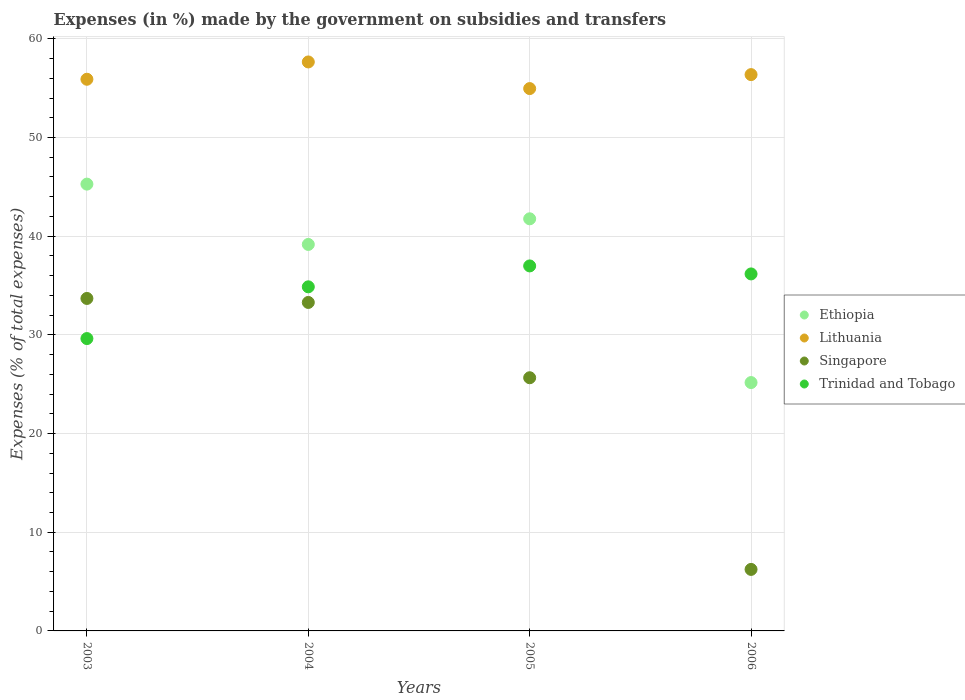Is the number of dotlines equal to the number of legend labels?
Your answer should be compact. Yes. What is the percentage of expenses made by the government on subsidies and transfers in Trinidad and Tobago in 2003?
Make the answer very short. 29.62. Across all years, what is the maximum percentage of expenses made by the government on subsidies and transfers in Lithuania?
Your response must be concise. 57.65. Across all years, what is the minimum percentage of expenses made by the government on subsidies and transfers in Lithuania?
Offer a very short reply. 54.96. What is the total percentage of expenses made by the government on subsidies and transfers in Lithuania in the graph?
Your answer should be compact. 224.88. What is the difference between the percentage of expenses made by the government on subsidies and transfers in Lithuania in 2004 and that in 2006?
Make the answer very short. 1.28. What is the difference between the percentage of expenses made by the government on subsidies and transfers in Lithuania in 2006 and the percentage of expenses made by the government on subsidies and transfers in Trinidad and Tobago in 2003?
Your response must be concise. 26.75. What is the average percentage of expenses made by the government on subsidies and transfers in Singapore per year?
Make the answer very short. 24.72. In the year 2004, what is the difference between the percentage of expenses made by the government on subsidies and transfers in Ethiopia and percentage of expenses made by the government on subsidies and transfers in Singapore?
Ensure brevity in your answer.  5.88. In how many years, is the percentage of expenses made by the government on subsidies and transfers in Ethiopia greater than 50 %?
Keep it short and to the point. 0. What is the ratio of the percentage of expenses made by the government on subsidies and transfers in Trinidad and Tobago in 2004 to that in 2005?
Ensure brevity in your answer.  0.94. What is the difference between the highest and the second highest percentage of expenses made by the government on subsidies and transfers in Ethiopia?
Offer a very short reply. 3.51. What is the difference between the highest and the lowest percentage of expenses made by the government on subsidies and transfers in Singapore?
Provide a short and direct response. 27.46. Is it the case that in every year, the sum of the percentage of expenses made by the government on subsidies and transfers in Ethiopia and percentage of expenses made by the government on subsidies and transfers in Lithuania  is greater than the sum of percentage of expenses made by the government on subsidies and transfers in Singapore and percentage of expenses made by the government on subsidies and transfers in Trinidad and Tobago?
Your answer should be compact. Yes. Does the percentage of expenses made by the government on subsidies and transfers in Singapore monotonically increase over the years?
Keep it short and to the point. No. Is the percentage of expenses made by the government on subsidies and transfers in Lithuania strictly less than the percentage of expenses made by the government on subsidies and transfers in Trinidad and Tobago over the years?
Offer a very short reply. No. How many dotlines are there?
Your answer should be very brief. 4. How many years are there in the graph?
Offer a very short reply. 4. What is the difference between two consecutive major ticks on the Y-axis?
Offer a very short reply. 10. Where does the legend appear in the graph?
Keep it short and to the point. Center right. What is the title of the graph?
Your answer should be compact. Expenses (in %) made by the government on subsidies and transfers. What is the label or title of the X-axis?
Offer a terse response. Years. What is the label or title of the Y-axis?
Ensure brevity in your answer.  Expenses (% of total expenses). What is the Expenses (% of total expenses) of Ethiopia in 2003?
Provide a short and direct response. 45.27. What is the Expenses (% of total expenses) of Lithuania in 2003?
Offer a terse response. 55.9. What is the Expenses (% of total expenses) in Singapore in 2003?
Provide a succinct answer. 33.69. What is the Expenses (% of total expenses) in Trinidad and Tobago in 2003?
Your response must be concise. 29.62. What is the Expenses (% of total expenses) in Ethiopia in 2004?
Offer a terse response. 39.16. What is the Expenses (% of total expenses) in Lithuania in 2004?
Provide a short and direct response. 57.65. What is the Expenses (% of total expenses) of Singapore in 2004?
Offer a very short reply. 33.28. What is the Expenses (% of total expenses) in Trinidad and Tobago in 2004?
Provide a short and direct response. 34.87. What is the Expenses (% of total expenses) of Ethiopia in 2005?
Offer a terse response. 41.76. What is the Expenses (% of total expenses) of Lithuania in 2005?
Your answer should be compact. 54.96. What is the Expenses (% of total expenses) in Singapore in 2005?
Ensure brevity in your answer.  25.66. What is the Expenses (% of total expenses) of Trinidad and Tobago in 2005?
Your response must be concise. 36.99. What is the Expenses (% of total expenses) in Ethiopia in 2006?
Your answer should be very brief. 25.17. What is the Expenses (% of total expenses) in Lithuania in 2006?
Offer a terse response. 56.37. What is the Expenses (% of total expenses) in Singapore in 2006?
Your answer should be very brief. 6.23. What is the Expenses (% of total expenses) in Trinidad and Tobago in 2006?
Ensure brevity in your answer.  36.17. Across all years, what is the maximum Expenses (% of total expenses) in Ethiopia?
Offer a terse response. 45.27. Across all years, what is the maximum Expenses (% of total expenses) of Lithuania?
Your answer should be compact. 57.65. Across all years, what is the maximum Expenses (% of total expenses) of Singapore?
Keep it short and to the point. 33.69. Across all years, what is the maximum Expenses (% of total expenses) of Trinidad and Tobago?
Give a very brief answer. 36.99. Across all years, what is the minimum Expenses (% of total expenses) of Ethiopia?
Provide a short and direct response. 25.17. Across all years, what is the minimum Expenses (% of total expenses) in Lithuania?
Offer a terse response. 54.96. Across all years, what is the minimum Expenses (% of total expenses) in Singapore?
Provide a succinct answer. 6.23. Across all years, what is the minimum Expenses (% of total expenses) in Trinidad and Tobago?
Provide a succinct answer. 29.62. What is the total Expenses (% of total expenses) of Ethiopia in the graph?
Provide a succinct answer. 151.36. What is the total Expenses (% of total expenses) of Lithuania in the graph?
Ensure brevity in your answer.  224.88. What is the total Expenses (% of total expenses) of Singapore in the graph?
Keep it short and to the point. 98.86. What is the total Expenses (% of total expenses) of Trinidad and Tobago in the graph?
Make the answer very short. 137.65. What is the difference between the Expenses (% of total expenses) in Ethiopia in 2003 and that in 2004?
Your response must be concise. 6.11. What is the difference between the Expenses (% of total expenses) of Lithuania in 2003 and that in 2004?
Keep it short and to the point. -1.75. What is the difference between the Expenses (% of total expenses) of Singapore in 2003 and that in 2004?
Provide a succinct answer. 0.41. What is the difference between the Expenses (% of total expenses) in Trinidad and Tobago in 2003 and that in 2004?
Your response must be concise. -5.24. What is the difference between the Expenses (% of total expenses) of Ethiopia in 2003 and that in 2005?
Keep it short and to the point. 3.51. What is the difference between the Expenses (% of total expenses) in Lithuania in 2003 and that in 2005?
Offer a terse response. 0.94. What is the difference between the Expenses (% of total expenses) in Singapore in 2003 and that in 2005?
Your response must be concise. 8.03. What is the difference between the Expenses (% of total expenses) of Trinidad and Tobago in 2003 and that in 2005?
Provide a short and direct response. -7.36. What is the difference between the Expenses (% of total expenses) of Ethiopia in 2003 and that in 2006?
Keep it short and to the point. 20.11. What is the difference between the Expenses (% of total expenses) of Lithuania in 2003 and that in 2006?
Provide a short and direct response. -0.47. What is the difference between the Expenses (% of total expenses) of Singapore in 2003 and that in 2006?
Provide a short and direct response. 27.46. What is the difference between the Expenses (% of total expenses) in Trinidad and Tobago in 2003 and that in 2006?
Your answer should be very brief. -6.55. What is the difference between the Expenses (% of total expenses) in Ethiopia in 2004 and that in 2005?
Ensure brevity in your answer.  -2.6. What is the difference between the Expenses (% of total expenses) in Lithuania in 2004 and that in 2005?
Your answer should be very brief. 2.7. What is the difference between the Expenses (% of total expenses) of Singapore in 2004 and that in 2005?
Offer a terse response. 7.63. What is the difference between the Expenses (% of total expenses) in Trinidad and Tobago in 2004 and that in 2005?
Offer a very short reply. -2.12. What is the difference between the Expenses (% of total expenses) in Ethiopia in 2004 and that in 2006?
Keep it short and to the point. 14. What is the difference between the Expenses (% of total expenses) of Lithuania in 2004 and that in 2006?
Provide a short and direct response. 1.28. What is the difference between the Expenses (% of total expenses) in Singapore in 2004 and that in 2006?
Keep it short and to the point. 27.05. What is the difference between the Expenses (% of total expenses) in Trinidad and Tobago in 2004 and that in 2006?
Your answer should be very brief. -1.31. What is the difference between the Expenses (% of total expenses) of Ethiopia in 2005 and that in 2006?
Offer a very short reply. 16.59. What is the difference between the Expenses (% of total expenses) in Lithuania in 2005 and that in 2006?
Provide a succinct answer. -1.42. What is the difference between the Expenses (% of total expenses) of Singapore in 2005 and that in 2006?
Provide a succinct answer. 19.42. What is the difference between the Expenses (% of total expenses) of Trinidad and Tobago in 2005 and that in 2006?
Your answer should be very brief. 0.81. What is the difference between the Expenses (% of total expenses) in Ethiopia in 2003 and the Expenses (% of total expenses) in Lithuania in 2004?
Ensure brevity in your answer.  -12.38. What is the difference between the Expenses (% of total expenses) of Ethiopia in 2003 and the Expenses (% of total expenses) of Singapore in 2004?
Provide a short and direct response. 11.99. What is the difference between the Expenses (% of total expenses) of Ethiopia in 2003 and the Expenses (% of total expenses) of Trinidad and Tobago in 2004?
Your response must be concise. 10.41. What is the difference between the Expenses (% of total expenses) of Lithuania in 2003 and the Expenses (% of total expenses) of Singapore in 2004?
Make the answer very short. 22.62. What is the difference between the Expenses (% of total expenses) of Lithuania in 2003 and the Expenses (% of total expenses) of Trinidad and Tobago in 2004?
Offer a terse response. 21.03. What is the difference between the Expenses (% of total expenses) of Singapore in 2003 and the Expenses (% of total expenses) of Trinidad and Tobago in 2004?
Your answer should be compact. -1.18. What is the difference between the Expenses (% of total expenses) in Ethiopia in 2003 and the Expenses (% of total expenses) in Lithuania in 2005?
Offer a terse response. -9.68. What is the difference between the Expenses (% of total expenses) in Ethiopia in 2003 and the Expenses (% of total expenses) in Singapore in 2005?
Give a very brief answer. 19.62. What is the difference between the Expenses (% of total expenses) of Ethiopia in 2003 and the Expenses (% of total expenses) of Trinidad and Tobago in 2005?
Your answer should be compact. 8.29. What is the difference between the Expenses (% of total expenses) of Lithuania in 2003 and the Expenses (% of total expenses) of Singapore in 2005?
Offer a very short reply. 30.25. What is the difference between the Expenses (% of total expenses) in Lithuania in 2003 and the Expenses (% of total expenses) in Trinidad and Tobago in 2005?
Give a very brief answer. 18.92. What is the difference between the Expenses (% of total expenses) of Singapore in 2003 and the Expenses (% of total expenses) of Trinidad and Tobago in 2005?
Your answer should be compact. -3.3. What is the difference between the Expenses (% of total expenses) of Ethiopia in 2003 and the Expenses (% of total expenses) of Lithuania in 2006?
Offer a very short reply. -11.1. What is the difference between the Expenses (% of total expenses) in Ethiopia in 2003 and the Expenses (% of total expenses) in Singapore in 2006?
Keep it short and to the point. 39.04. What is the difference between the Expenses (% of total expenses) of Ethiopia in 2003 and the Expenses (% of total expenses) of Trinidad and Tobago in 2006?
Your response must be concise. 9.1. What is the difference between the Expenses (% of total expenses) of Lithuania in 2003 and the Expenses (% of total expenses) of Singapore in 2006?
Make the answer very short. 49.67. What is the difference between the Expenses (% of total expenses) of Lithuania in 2003 and the Expenses (% of total expenses) of Trinidad and Tobago in 2006?
Give a very brief answer. 19.73. What is the difference between the Expenses (% of total expenses) in Singapore in 2003 and the Expenses (% of total expenses) in Trinidad and Tobago in 2006?
Your response must be concise. -2.48. What is the difference between the Expenses (% of total expenses) of Ethiopia in 2004 and the Expenses (% of total expenses) of Lithuania in 2005?
Your response must be concise. -15.79. What is the difference between the Expenses (% of total expenses) of Ethiopia in 2004 and the Expenses (% of total expenses) of Singapore in 2005?
Your answer should be very brief. 13.51. What is the difference between the Expenses (% of total expenses) in Ethiopia in 2004 and the Expenses (% of total expenses) in Trinidad and Tobago in 2005?
Provide a succinct answer. 2.18. What is the difference between the Expenses (% of total expenses) of Lithuania in 2004 and the Expenses (% of total expenses) of Singapore in 2005?
Provide a succinct answer. 32. What is the difference between the Expenses (% of total expenses) of Lithuania in 2004 and the Expenses (% of total expenses) of Trinidad and Tobago in 2005?
Provide a short and direct response. 20.67. What is the difference between the Expenses (% of total expenses) in Singapore in 2004 and the Expenses (% of total expenses) in Trinidad and Tobago in 2005?
Make the answer very short. -3.7. What is the difference between the Expenses (% of total expenses) of Ethiopia in 2004 and the Expenses (% of total expenses) of Lithuania in 2006?
Ensure brevity in your answer.  -17.21. What is the difference between the Expenses (% of total expenses) of Ethiopia in 2004 and the Expenses (% of total expenses) of Singapore in 2006?
Provide a short and direct response. 32.93. What is the difference between the Expenses (% of total expenses) of Ethiopia in 2004 and the Expenses (% of total expenses) of Trinidad and Tobago in 2006?
Ensure brevity in your answer.  2.99. What is the difference between the Expenses (% of total expenses) of Lithuania in 2004 and the Expenses (% of total expenses) of Singapore in 2006?
Offer a terse response. 51.42. What is the difference between the Expenses (% of total expenses) of Lithuania in 2004 and the Expenses (% of total expenses) of Trinidad and Tobago in 2006?
Provide a succinct answer. 21.48. What is the difference between the Expenses (% of total expenses) in Singapore in 2004 and the Expenses (% of total expenses) in Trinidad and Tobago in 2006?
Keep it short and to the point. -2.89. What is the difference between the Expenses (% of total expenses) of Ethiopia in 2005 and the Expenses (% of total expenses) of Lithuania in 2006?
Offer a terse response. -14.61. What is the difference between the Expenses (% of total expenses) of Ethiopia in 2005 and the Expenses (% of total expenses) of Singapore in 2006?
Offer a very short reply. 35.53. What is the difference between the Expenses (% of total expenses) in Ethiopia in 2005 and the Expenses (% of total expenses) in Trinidad and Tobago in 2006?
Give a very brief answer. 5.58. What is the difference between the Expenses (% of total expenses) of Lithuania in 2005 and the Expenses (% of total expenses) of Singapore in 2006?
Give a very brief answer. 48.72. What is the difference between the Expenses (% of total expenses) in Lithuania in 2005 and the Expenses (% of total expenses) in Trinidad and Tobago in 2006?
Your answer should be compact. 18.78. What is the difference between the Expenses (% of total expenses) in Singapore in 2005 and the Expenses (% of total expenses) in Trinidad and Tobago in 2006?
Keep it short and to the point. -10.52. What is the average Expenses (% of total expenses) of Ethiopia per year?
Offer a very short reply. 37.84. What is the average Expenses (% of total expenses) of Lithuania per year?
Provide a succinct answer. 56.22. What is the average Expenses (% of total expenses) in Singapore per year?
Provide a short and direct response. 24.72. What is the average Expenses (% of total expenses) of Trinidad and Tobago per year?
Make the answer very short. 34.41. In the year 2003, what is the difference between the Expenses (% of total expenses) in Ethiopia and Expenses (% of total expenses) in Lithuania?
Give a very brief answer. -10.63. In the year 2003, what is the difference between the Expenses (% of total expenses) in Ethiopia and Expenses (% of total expenses) in Singapore?
Your answer should be very brief. 11.58. In the year 2003, what is the difference between the Expenses (% of total expenses) of Ethiopia and Expenses (% of total expenses) of Trinidad and Tobago?
Your answer should be compact. 15.65. In the year 2003, what is the difference between the Expenses (% of total expenses) of Lithuania and Expenses (% of total expenses) of Singapore?
Give a very brief answer. 22.21. In the year 2003, what is the difference between the Expenses (% of total expenses) in Lithuania and Expenses (% of total expenses) in Trinidad and Tobago?
Offer a terse response. 26.28. In the year 2003, what is the difference between the Expenses (% of total expenses) in Singapore and Expenses (% of total expenses) in Trinidad and Tobago?
Offer a very short reply. 4.07. In the year 2004, what is the difference between the Expenses (% of total expenses) in Ethiopia and Expenses (% of total expenses) in Lithuania?
Give a very brief answer. -18.49. In the year 2004, what is the difference between the Expenses (% of total expenses) in Ethiopia and Expenses (% of total expenses) in Singapore?
Ensure brevity in your answer.  5.88. In the year 2004, what is the difference between the Expenses (% of total expenses) in Ethiopia and Expenses (% of total expenses) in Trinidad and Tobago?
Keep it short and to the point. 4.3. In the year 2004, what is the difference between the Expenses (% of total expenses) of Lithuania and Expenses (% of total expenses) of Singapore?
Provide a succinct answer. 24.37. In the year 2004, what is the difference between the Expenses (% of total expenses) in Lithuania and Expenses (% of total expenses) in Trinidad and Tobago?
Your answer should be very brief. 22.79. In the year 2004, what is the difference between the Expenses (% of total expenses) of Singapore and Expenses (% of total expenses) of Trinidad and Tobago?
Provide a short and direct response. -1.58. In the year 2005, what is the difference between the Expenses (% of total expenses) in Ethiopia and Expenses (% of total expenses) in Lithuania?
Provide a succinct answer. -13.2. In the year 2005, what is the difference between the Expenses (% of total expenses) in Ethiopia and Expenses (% of total expenses) in Singapore?
Your response must be concise. 16.1. In the year 2005, what is the difference between the Expenses (% of total expenses) in Ethiopia and Expenses (% of total expenses) in Trinidad and Tobago?
Your answer should be compact. 4.77. In the year 2005, what is the difference between the Expenses (% of total expenses) in Lithuania and Expenses (% of total expenses) in Singapore?
Give a very brief answer. 29.3. In the year 2005, what is the difference between the Expenses (% of total expenses) in Lithuania and Expenses (% of total expenses) in Trinidad and Tobago?
Provide a succinct answer. 17.97. In the year 2005, what is the difference between the Expenses (% of total expenses) in Singapore and Expenses (% of total expenses) in Trinidad and Tobago?
Your answer should be very brief. -11.33. In the year 2006, what is the difference between the Expenses (% of total expenses) of Ethiopia and Expenses (% of total expenses) of Lithuania?
Your response must be concise. -31.21. In the year 2006, what is the difference between the Expenses (% of total expenses) of Ethiopia and Expenses (% of total expenses) of Singapore?
Your response must be concise. 18.93. In the year 2006, what is the difference between the Expenses (% of total expenses) of Ethiopia and Expenses (% of total expenses) of Trinidad and Tobago?
Your answer should be compact. -11.01. In the year 2006, what is the difference between the Expenses (% of total expenses) of Lithuania and Expenses (% of total expenses) of Singapore?
Offer a terse response. 50.14. In the year 2006, what is the difference between the Expenses (% of total expenses) in Lithuania and Expenses (% of total expenses) in Trinidad and Tobago?
Provide a short and direct response. 20.2. In the year 2006, what is the difference between the Expenses (% of total expenses) in Singapore and Expenses (% of total expenses) in Trinidad and Tobago?
Your answer should be very brief. -29.94. What is the ratio of the Expenses (% of total expenses) of Ethiopia in 2003 to that in 2004?
Provide a succinct answer. 1.16. What is the ratio of the Expenses (% of total expenses) in Lithuania in 2003 to that in 2004?
Your response must be concise. 0.97. What is the ratio of the Expenses (% of total expenses) of Singapore in 2003 to that in 2004?
Ensure brevity in your answer.  1.01. What is the ratio of the Expenses (% of total expenses) in Trinidad and Tobago in 2003 to that in 2004?
Make the answer very short. 0.85. What is the ratio of the Expenses (% of total expenses) of Ethiopia in 2003 to that in 2005?
Provide a short and direct response. 1.08. What is the ratio of the Expenses (% of total expenses) in Lithuania in 2003 to that in 2005?
Offer a terse response. 1.02. What is the ratio of the Expenses (% of total expenses) in Singapore in 2003 to that in 2005?
Offer a terse response. 1.31. What is the ratio of the Expenses (% of total expenses) in Trinidad and Tobago in 2003 to that in 2005?
Provide a short and direct response. 0.8. What is the ratio of the Expenses (% of total expenses) in Ethiopia in 2003 to that in 2006?
Your response must be concise. 1.8. What is the ratio of the Expenses (% of total expenses) of Singapore in 2003 to that in 2006?
Keep it short and to the point. 5.4. What is the ratio of the Expenses (% of total expenses) in Trinidad and Tobago in 2003 to that in 2006?
Provide a short and direct response. 0.82. What is the ratio of the Expenses (% of total expenses) in Ethiopia in 2004 to that in 2005?
Give a very brief answer. 0.94. What is the ratio of the Expenses (% of total expenses) in Lithuania in 2004 to that in 2005?
Your response must be concise. 1.05. What is the ratio of the Expenses (% of total expenses) of Singapore in 2004 to that in 2005?
Offer a terse response. 1.3. What is the ratio of the Expenses (% of total expenses) in Trinidad and Tobago in 2004 to that in 2005?
Give a very brief answer. 0.94. What is the ratio of the Expenses (% of total expenses) of Ethiopia in 2004 to that in 2006?
Give a very brief answer. 1.56. What is the ratio of the Expenses (% of total expenses) in Lithuania in 2004 to that in 2006?
Your response must be concise. 1.02. What is the ratio of the Expenses (% of total expenses) of Singapore in 2004 to that in 2006?
Provide a short and direct response. 5.34. What is the ratio of the Expenses (% of total expenses) in Trinidad and Tobago in 2004 to that in 2006?
Make the answer very short. 0.96. What is the ratio of the Expenses (% of total expenses) in Ethiopia in 2005 to that in 2006?
Your response must be concise. 1.66. What is the ratio of the Expenses (% of total expenses) of Lithuania in 2005 to that in 2006?
Make the answer very short. 0.97. What is the ratio of the Expenses (% of total expenses) of Singapore in 2005 to that in 2006?
Provide a succinct answer. 4.12. What is the ratio of the Expenses (% of total expenses) of Trinidad and Tobago in 2005 to that in 2006?
Your answer should be compact. 1.02. What is the difference between the highest and the second highest Expenses (% of total expenses) in Ethiopia?
Make the answer very short. 3.51. What is the difference between the highest and the second highest Expenses (% of total expenses) of Lithuania?
Keep it short and to the point. 1.28. What is the difference between the highest and the second highest Expenses (% of total expenses) in Singapore?
Ensure brevity in your answer.  0.41. What is the difference between the highest and the second highest Expenses (% of total expenses) in Trinidad and Tobago?
Your answer should be very brief. 0.81. What is the difference between the highest and the lowest Expenses (% of total expenses) in Ethiopia?
Your answer should be very brief. 20.11. What is the difference between the highest and the lowest Expenses (% of total expenses) of Lithuania?
Your answer should be very brief. 2.7. What is the difference between the highest and the lowest Expenses (% of total expenses) in Singapore?
Make the answer very short. 27.46. What is the difference between the highest and the lowest Expenses (% of total expenses) of Trinidad and Tobago?
Provide a short and direct response. 7.36. 